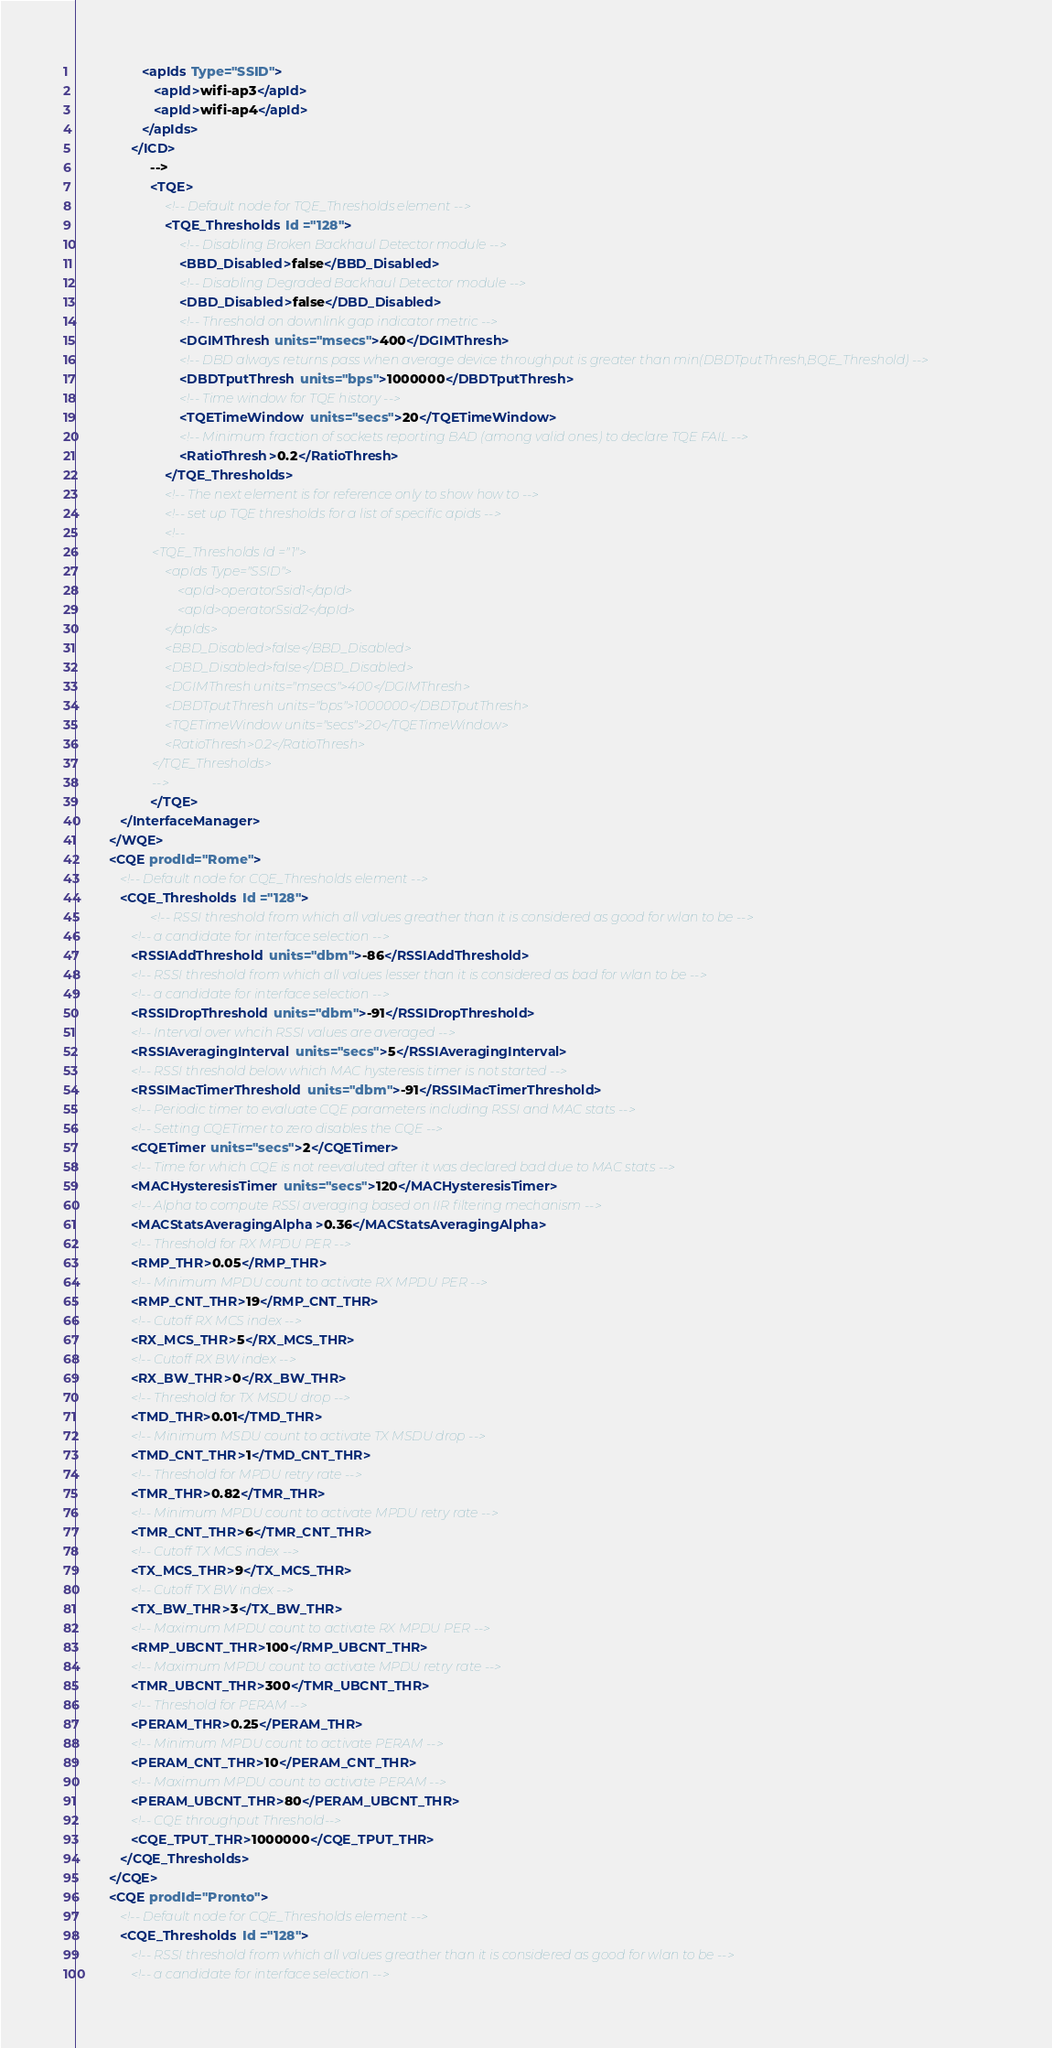Convert code to text. <code><loc_0><loc_0><loc_500><loc_500><_XML_>                  <apIds Type="SSID">
                     <apId>wifi-ap3</apId>
                     <apId>wifi-ap4</apId>
                  </apIds>
               </ICD>
                    -->
                    <TQE>
                        <!-- Default node for TQE_Thresholds element -->
                        <TQE_Thresholds Id ="128">
                            <!-- Disabling Broken Backhaul Detector module -->
                            <BBD_Disabled>false</BBD_Disabled>
                            <!-- Disabling Degraded Backhaul Detector module -->
                            <DBD_Disabled>false</DBD_Disabled>
                            <!-- Threshold on downlink gap indicator metric -->
                            <DGIMThresh units="msecs">400</DGIMThresh>
                            <!-- DBD always returns pass when average device throughput is greater than min(DBDTputThresh,BQE_Threshold) -->
                            <DBDTputThresh units="bps">1000000</DBDTputThresh>
                            <!-- Time window for TQE history -->
                            <TQETimeWindow units="secs">20</TQETimeWindow>
                            <!-- Minimum fraction of sockets reporting BAD (among valid ones) to declare TQE FAIL -->
                            <RatioThresh>0.2</RatioThresh>
                        </TQE_Thresholds>
                        <!-- The next element is for reference only to show how to -->
                        <!-- set up TQE thresholds for a list of specific apids -->
                        <!--
                        <TQE_Thresholds Id ="1">
                            <apIds Type="SSID">
                                <apId>operatorSsid1</apId>
                                <apId>operatorSsid2</apId>
                            </apIds>
                            <BBD_Disabled>false</BBD_Disabled>
                            <DBD_Disabled>false</DBD_Disabled>
                            <DGIMThresh units="msecs">400</DGIMThresh>
                            <DBDTputThresh units="bps">1000000</DBDTputThresh>
                            <TQETimeWindow units="secs">20</TQETimeWindow>
                            <RatioThresh>0.2</RatioThresh>
                        </TQE_Thresholds>
                        -->
                    </TQE>
            </InterfaceManager>
         </WQE>
         <CQE prodId="Rome">
            <!-- Default node for CQE_Thresholds element -->
            <CQE_Thresholds Id ="128">
                    <!-- RSSI threshold from which all values greather than it is considered as good for wlan to be -->
               <!-- a candidate for interface selection -->
               <RSSIAddThreshold units="dbm">-86</RSSIAddThreshold>
               <!-- RSSI threshold from which all values lesser than it is considered as bad for wlan to be -->
               <!-- a candidate for interface selection -->
               <RSSIDropThreshold units="dbm">-91</RSSIDropThreshold>
               <!-- Interval over whcih RSSI values are averaged -->
               <RSSIAveragingInterval units="secs">5</RSSIAveragingInterval>
               <!-- RSSI threshold below which MAC hysteresis timer is not started -->
               <RSSIMacTimerThreshold units="dbm">-91</RSSIMacTimerThreshold>
               <!-- Periodic timer to evaluate CQE parameters including RSSI and MAC stats -->
               <!-- Setting CQETimer to zero disables the CQE -->
               <CQETimer units="secs">2</CQETimer>
               <!-- Time for which CQE is not reevaluted after it was declared bad due to MAC stats -->
               <MACHysteresisTimer units="secs">120</MACHysteresisTimer>
               <!-- Alpha to compute RSSI averaging based on IIR filtering mechanism -->
               <MACStatsAveragingAlpha>0.36</MACStatsAveragingAlpha>
               <!-- Threshold for RX MPDU PER -->
               <RMP_THR>0.05</RMP_THR>
               <!-- Minimum MPDU count to activate RX MPDU PER -->
               <RMP_CNT_THR>19</RMP_CNT_THR>
               <!-- Cutoff RX MCS index -->
               <RX_MCS_THR>5</RX_MCS_THR>
               <!-- Cutoff RX BW index -->
               <RX_BW_THR>0</RX_BW_THR>
               <!-- Threshold for TX MSDU drop -->
               <TMD_THR>0.01</TMD_THR>
               <!-- Minimum MSDU count to activate TX MSDU drop -->
               <TMD_CNT_THR>1</TMD_CNT_THR>
               <!-- Threshold for MPDU retry rate -->
               <TMR_THR>0.82</TMR_THR>
               <!-- Minimum MPDU count to activate MPDU retry rate -->
               <TMR_CNT_THR>6</TMR_CNT_THR>
               <!-- Cutoff TX MCS index -->
               <TX_MCS_THR>9</TX_MCS_THR>
               <!-- Cutoff TX BW index -->
               <TX_BW_THR>3</TX_BW_THR>
               <!-- Maximum MPDU count to activate RX MPDU PER -->
               <RMP_UBCNT_THR>100</RMP_UBCNT_THR>
               <!-- Maximum MPDU count to activate MPDU retry rate -->
               <TMR_UBCNT_THR>300</TMR_UBCNT_THR>
               <!-- Threshold for PERAM -->
               <PERAM_THR>0.25</PERAM_THR>
               <!-- Minimum MPDU count to activate PERAM -->
               <PERAM_CNT_THR>10</PERAM_CNT_THR>
               <!-- Maximum MPDU count to activate PERAM -->
               <PERAM_UBCNT_THR>80</PERAM_UBCNT_THR>
               <!-- CQE throughput Threshold-->
               <CQE_TPUT_THR>1000000</CQE_TPUT_THR>
            </CQE_Thresholds>
         </CQE>
         <CQE prodId="Pronto">
            <!-- Default node for CQE_Thresholds element -->
            <CQE_Thresholds Id ="128">
               <!-- RSSI threshold from which all values greather than it is considered as good for wlan to be -->
               <!-- a candidate for interface selection --></code> 